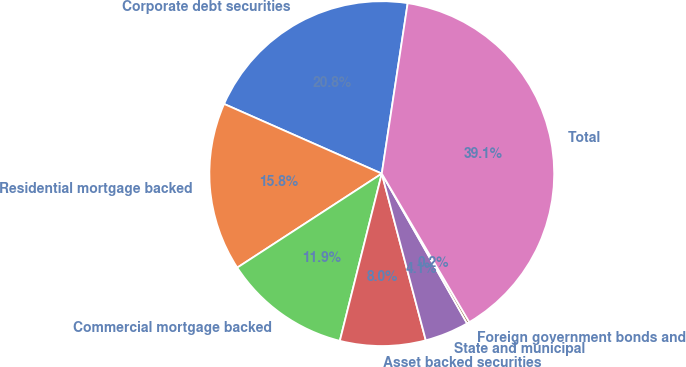Convert chart to OTSL. <chart><loc_0><loc_0><loc_500><loc_500><pie_chart><fcel>Corporate debt securities<fcel>Residential mortgage backed<fcel>Commercial mortgage backed<fcel>Asset backed securities<fcel>State and municipal<fcel>Foreign government bonds and<fcel>Total<nl><fcel>20.78%<fcel>15.8%<fcel>11.91%<fcel>8.02%<fcel>4.13%<fcel>0.24%<fcel>39.12%<nl></chart> 